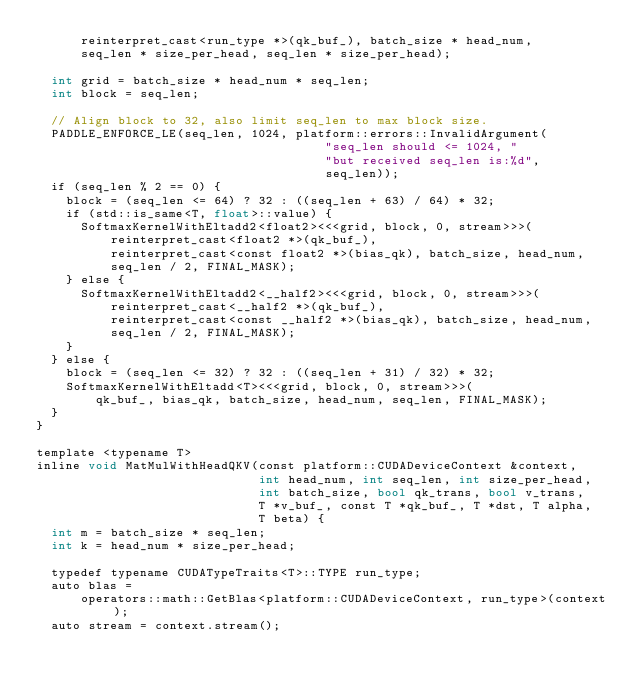Convert code to text. <code><loc_0><loc_0><loc_500><loc_500><_Cuda_>      reinterpret_cast<run_type *>(qk_buf_), batch_size * head_num,
      seq_len * size_per_head, seq_len * size_per_head);

  int grid = batch_size * head_num * seq_len;
  int block = seq_len;

  // Align block to 32, also limit seq_len to max block size.
  PADDLE_ENFORCE_LE(seq_len, 1024, platform::errors::InvalidArgument(
                                       "seq_len should <= 1024, "
                                       "but received seq_len is:%d",
                                       seq_len));
  if (seq_len % 2 == 0) {
    block = (seq_len <= 64) ? 32 : ((seq_len + 63) / 64) * 32;
    if (std::is_same<T, float>::value) {
      SoftmaxKernelWithEltadd2<float2><<<grid, block, 0, stream>>>(
          reinterpret_cast<float2 *>(qk_buf_),
          reinterpret_cast<const float2 *>(bias_qk), batch_size, head_num,
          seq_len / 2, FINAL_MASK);
    } else {
      SoftmaxKernelWithEltadd2<__half2><<<grid, block, 0, stream>>>(
          reinterpret_cast<__half2 *>(qk_buf_),
          reinterpret_cast<const __half2 *>(bias_qk), batch_size, head_num,
          seq_len / 2, FINAL_MASK);
    }
  } else {
    block = (seq_len <= 32) ? 32 : ((seq_len + 31) / 32) * 32;
    SoftmaxKernelWithEltadd<T><<<grid, block, 0, stream>>>(
        qk_buf_, bias_qk, batch_size, head_num, seq_len, FINAL_MASK);
  }
}

template <typename T>
inline void MatMulWithHeadQKV(const platform::CUDADeviceContext &context,
                              int head_num, int seq_len, int size_per_head,
                              int batch_size, bool qk_trans, bool v_trans,
                              T *v_buf_, const T *qk_buf_, T *dst, T alpha,
                              T beta) {
  int m = batch_size * seq_len;
  int k = head_num * size_per_head;

  typedef typename CUDATypeTraits<T>::TYPE run_type;
  auto blas =
      operators::math::GetBlas<platform::CUDADeviceContext, run_type>(context);
  auto stream = context.stream();</code> 